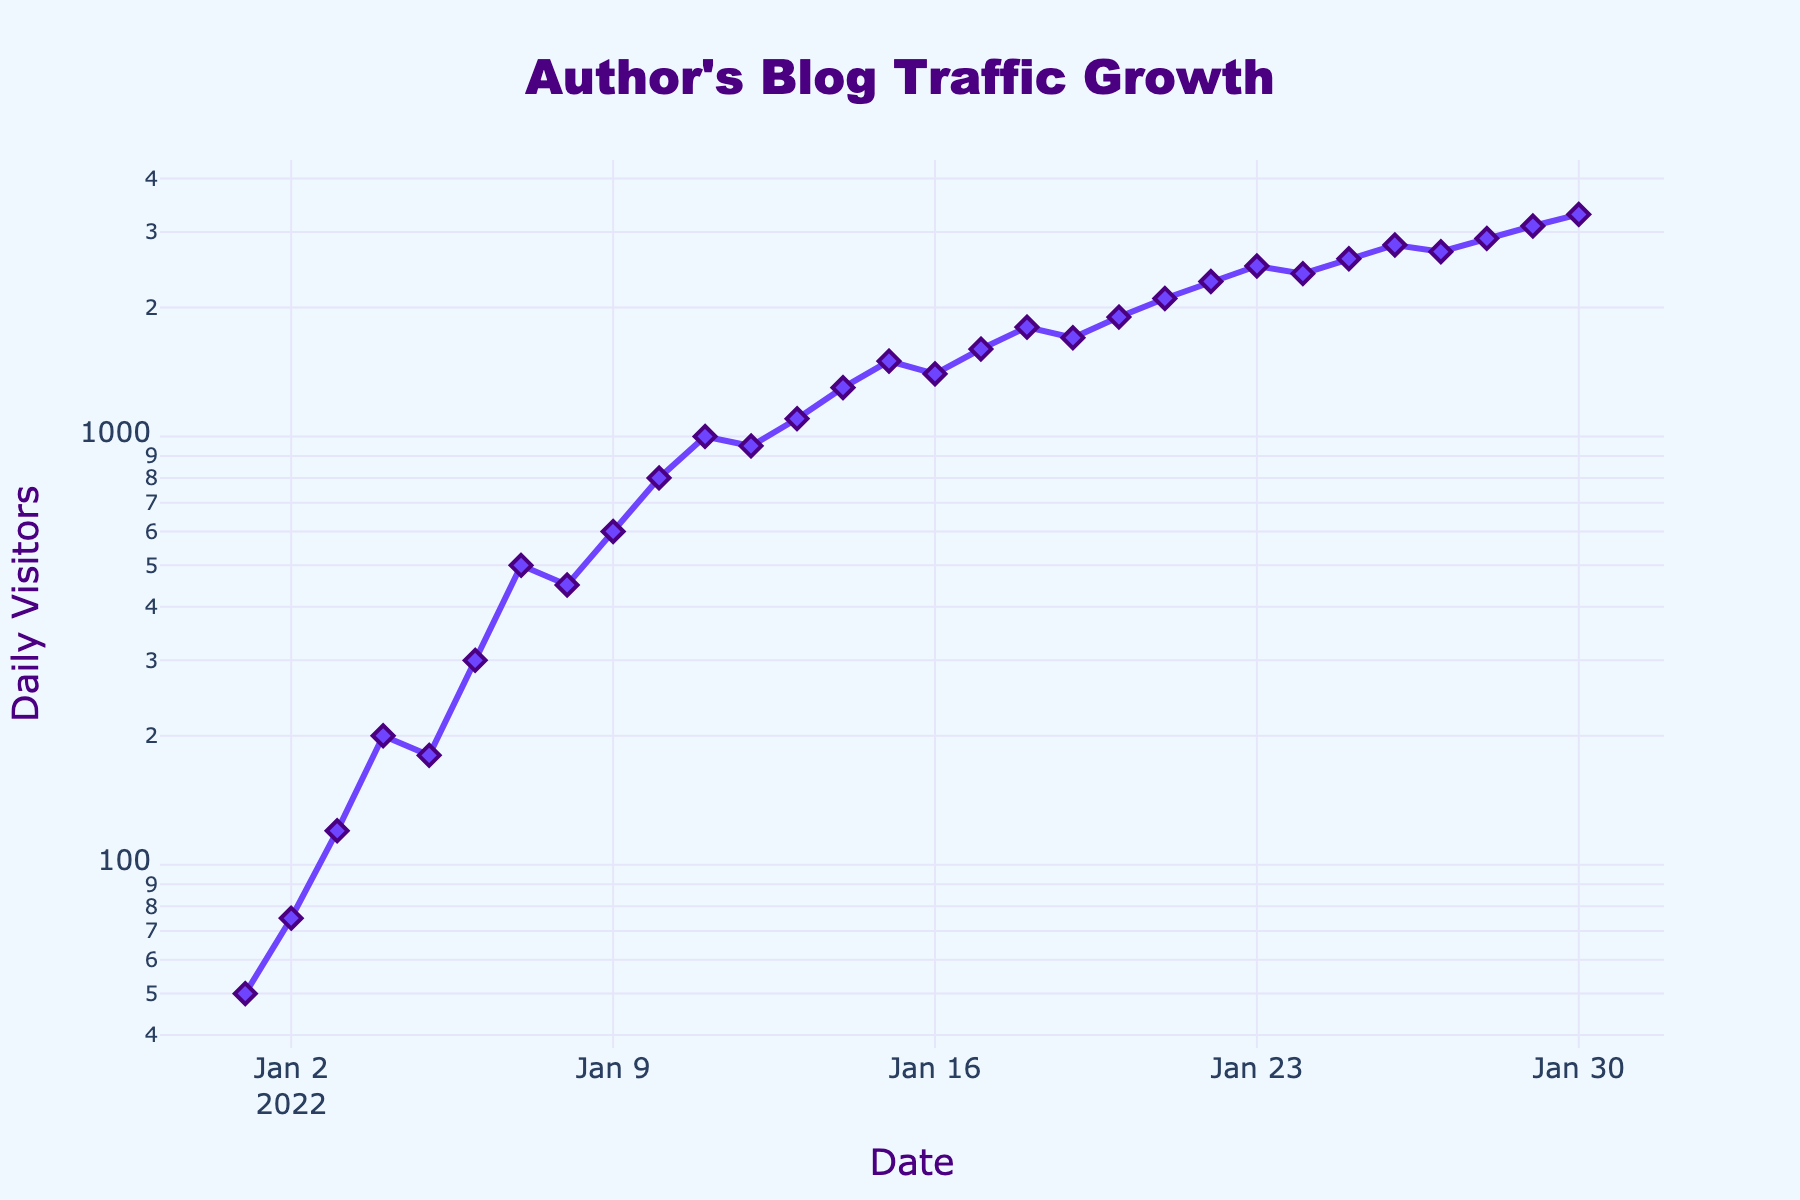What's the title of this figure? The title is positioned at the top of the plot, which clearly indicates the content of the figure.
Answer: Author's Blog Traffic Growth How many total data points are there in the figure? By counting the markers or data points along the line, we can see that there are exactly 30 days of recorded traffic since each day is represented as a single point.
Answer: 30 What is the log scale used for in this figure? The y-axis is on a logarithmic scale, which is typically used to represent data that varies over a large range, showing exponential growth clearly.
Answer: y-axis On which date did the blog receive exactly 200 daily visitors? By looking at the intersection of the line and the horizontal grid line at the y-value 200, and matching it to the respective date on the x-axis, it can be observed.
Answer: 2022-01-04 What was the increase in daily visitors from 2022-01-01 to 2022-01-07? The number of daily visitors on 2022-01-01 was 50, and on 2022-01-07 it was 500. Subtracting the former from the latter gives the increase. 500 - 50 = 450
Answer: 450 Which day experienced a drop in daily visitors from the previous day? Observing the trends in the line, a drop is seen when the value decreases from one day to the next. On 2022-01-12 (950 visitors) after 2022-01-11 (1000 visitors), there is a decrease in visitors.
Answer: 2022-01-12 Between which two consecutive days was the largest increase in daily visitors? By comparing the differences in daily visitors for each consecutive day, the largest increase is located between 2022-01-10 (800 visitors) and 2022-01-11 (1000 visitors) which is 1000 - 800 = 200.
Answer: 2022-01-10 to 2022-01-11 What is the trend observed in the time series plot? Analyzing the overall pattern and direction of the plotted line, it shows a generally increasing trend in daily visitors to the blog over the time period.
Answer: Increasing What is the range of the daily visitors depicted in the figure? The minimum value at the starting date is 50 visitors, and the maximum value at the end date is 3300 visitors. The range is calculated by subtracting the minimum from the maximum. 3300 - 50 = 3250.
Answer: 3250 